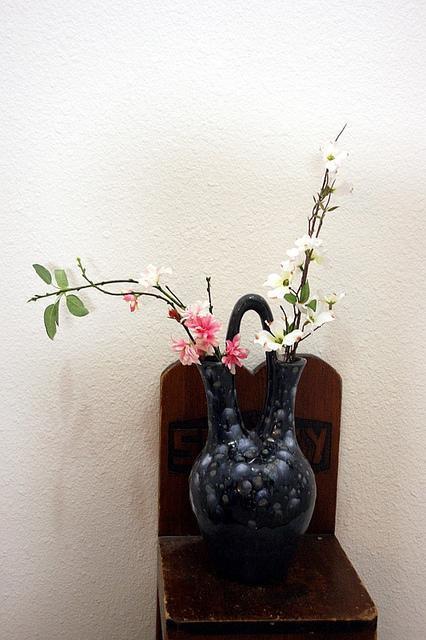How many openings does the vase have?
Give a very brief answer. 2. How many men are wearing white?
Give a very brief answer. 0. 